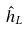<formula> <loc_0><loc_0><loc_500><loc_500>\hat { h } _ { L }</formula> 